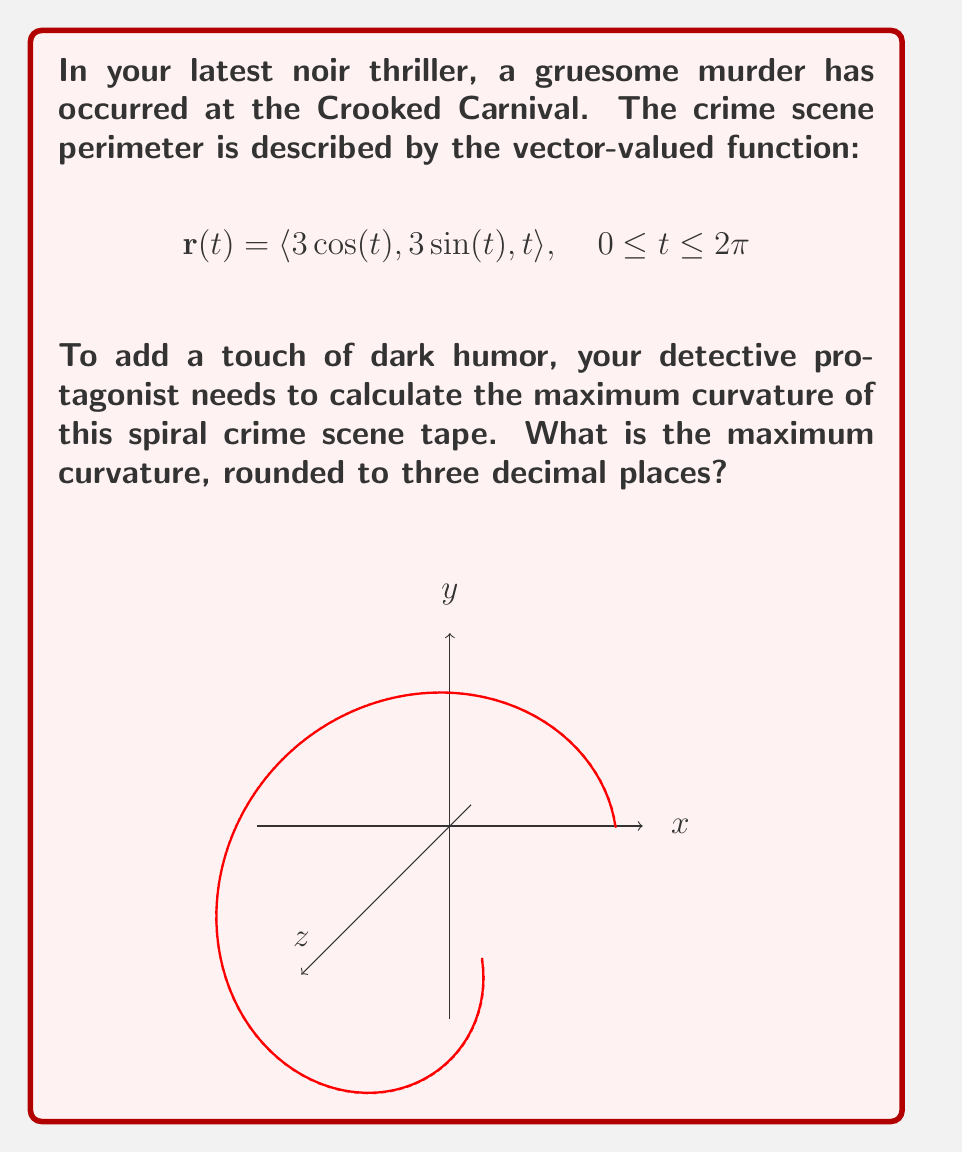Show me your answer to this math problem. Let's approach this step-by-step:

1) The curvature of a vector-valued function is given by:

   $$\kappa = \frac{|\mathbf{r}'(t) \times \mathbf{r}''(t)|}{|\mathbf{r}'(t)|^3}$$

2) First, we need to find $\mathbf{r}'(t)$ and $\mathbf{r}''(t)$:

   $$\mathbf{r}'(t) = \langle -3\sin(t), 3\cos(t), 1 \rangle$$
   $$\mathbf{r}''(t) = \langle -3\cos(t), -3\sin(t), 0 \rangle$$

3) Now, let's calculate $\mathbf{r}'(t) \times \mathbf{r}''(t)$:

   $$\mathbf{r}'(t) \times \mathbf{r}''(t) = \langle 3\sin(t), -3\cos(t), -9 \rangle$$

4) The magnitude of this cross product is:

   $$|\mathbf{r}'(t) \times \mathbf{r}''(t)| = \sqrt{9\sin^2(t) + 9\cos^2(t) + 81} = \sqrt{90} = 3\sqrt{10}$$

5) Next, we need $|\mathbf{r}'(t)|^3$:

   $$|\mathbf{r}'(t)| = \sqrt{9\sin^2(t) + 9\cos^2(t) + 1} = \sqrt{10}$$
   $$|\mathbf{r}'(t)|^3 = (\sqrt{10})^3 = 10\sqrt{10}$$

6) Now we can calculate the curvature:

   $$\kappa = \frac{3\sqrt{10}}{10\sqrt{10}} = \frac{3}{10} = 0.3$$

7) The curvature is constant, so this is also the maximum curvature.
Answer: 0.300 